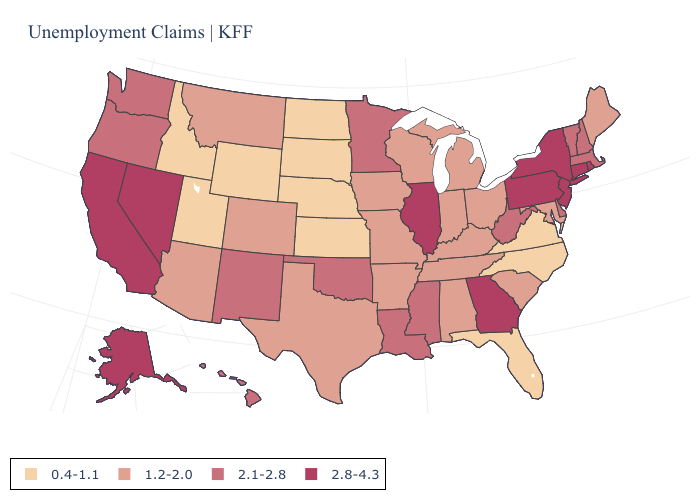Does the first symbol in the legend represent the smallest category?
Concise answer only. Yes. What is the value of West Virginia?
Quick response, please. 2.1-2.8. Which states hav the highest value in the Northeast?
Be succinct. Connecticut, New Jersey, New York, Pennsylvania, Rhode Island. Which states have the lowest value in the USA?
Be succinct. Florida, Idaho, Kansas, Nebraska, North Carolina, North Dakota, South Dakota, Utah, Virginia, Wyoming. Name the states that have a value in the range 2.8-4.3?
Concise answer only. Alaska, California, Connecticut, Georgia, Illinois, Nevada, New Jersey, New York, Pennsylvania, Rhode Island. What is the lowest value in the USA?
Short answer required. 0.4-1.1. Does Georgia have a higher value than Utah?
Short answer required. Yes. Name the states that have a value in the range 1.2-2.0?
Concise answer only. Alabama, Arizona, Arkansas, Colorado, Indiana, Iowa, Kentucky, Maine, Maryland, Michigan, Missouri, Montana, Ohio, South Carolina, Tennessee, Texas, Wisconsin. What is the value of Arkansas?
Write a very short answer. 1.2-2.0. Does Maine have the lowest value in the Northeast?
Answer briefly. Yes. Name the states that have a value in the range 0.4-1.1?
Answer briefly. Florida, Idaho, Kansas, Nebraska, North Carolina, North Dakota, South Dakota, Utah, Virginia, Wyoming. Which states hav the highest value in the Northeast?
Be succinct. Connecticut, New Jersey, New York, Pennsylvania, Rhode Island. Does Massachusetts have a higher value than North Carolina?
Keep it brief. Yes. Which states have the lowest value in the USA?
Quick response, please. Florida, Idaho, Kansas, Nebraska, North Carolina, North Dakota, South Dakota, Utah, Virginia, Wyoming. Name the states that have a value in the range 1.2-2.0?
Answer briefly. Alabama, Arizona, Arkansas, Colorado, Indiana, Iowa, Kentucky, Maine, Maryland, Michigan, Missouri, Montana, Ohio, South Carolina, Tennessee, Texas, Wisconsin. 